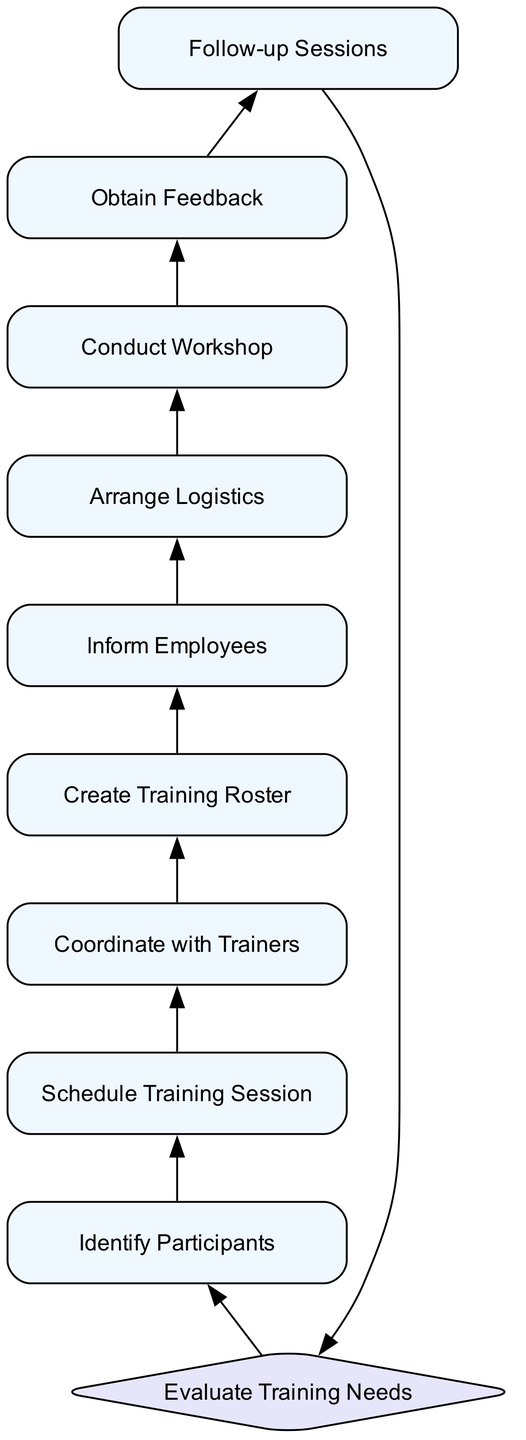What is the first step in scheduling training for bakery employees? The diagram shows that the first step is "Evaluate Training Needs," indicating that assessing skills and identifying areas for improvement is essential before proceeding with any other steps.
Answer: Evaluate Training Needs How many decision nodes are present in the diagram? There is only one decision node in the diagram, labeled "Evaluate Training Needs." This is determined by counting the nodes that are shaped like diamonds, which indicate decisions.
Answer: 1 What follows after identifying participants? According to the flow of the diagram, the step that follows "Identify Participants" is "Schedule Training Session," where dates and times for workshops are determined.
Answer: Schedule Training Session What is the last step in the training scheduling process? The last step in the diagram is "Follow-up Sessions," where additional sessions may be planned based on the feedback collected from previous training. This can be inferred from tracing the flow to the end of the diagram.
Answer: Follow-up Sessions How many total processes are involved in the diagram? The diagram includes eight process nodes that represent actions to be taken in the scheduling process, as seen by counting all nodes that are rectangle-shaped, excluding decision nodes.
Answer: 8 Which step directly leads to conducting the workshop? The step that directly leads to "Conduct Workshop" is "Arrange Logistics," which prepares all necessary elements for the training session as indicated in the flow connection between these two steps.
Answer: Arrange Logistics What happens after obtaining feedback? After "Obtain Feedback," the next step is "Follow-up Sessions," indicating that insights gained from feedback are used to plan future training activities. This can be traced in the flow from one process to the next.
Answer: Follow-up Sessions What is the relationship between scheduling training and coordinating with trainers? The relationship is sequential; after "Schedule Training Session," the next step is "Coordinate with Trainers," meaning that confirming trainer availability happens only after the session dates have been set.
Answer: Sequential Which process involves notifying employees? The process responsible for notifying employees about the training schedule is called "Inform Employees," which occurs after compiling the roster of attendees. This can be traced in the flow from "Create Training Roster" to "Inform Employees."
Answer: Inform Employees 